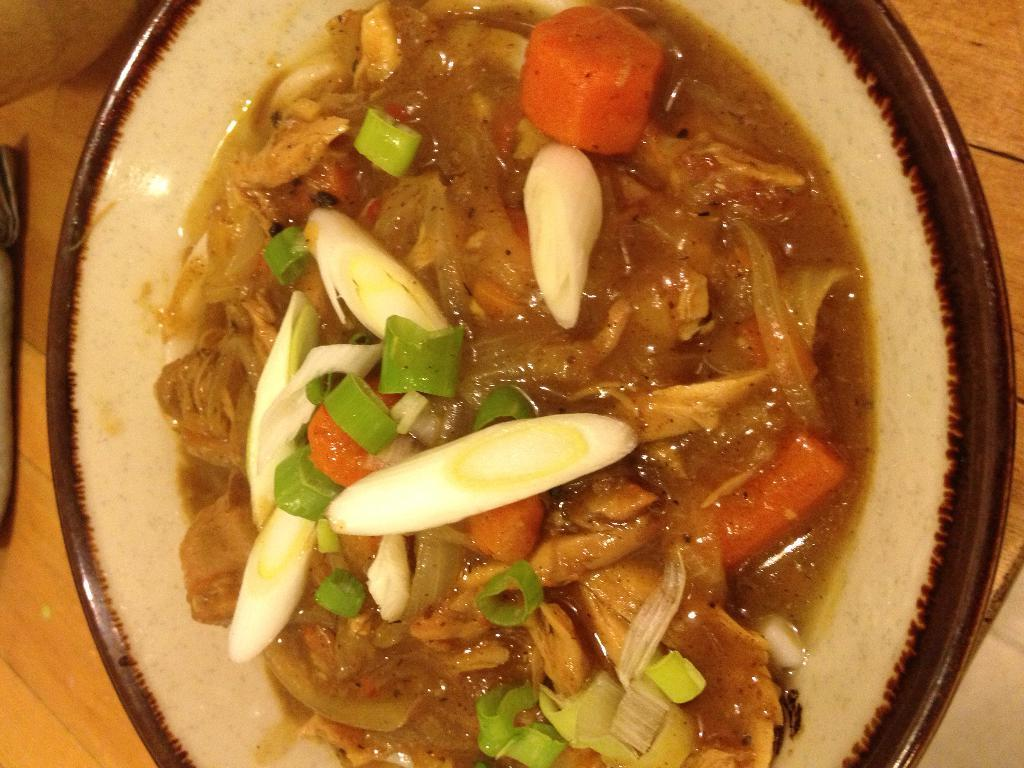What is on the plate that is visible in the image? There is a plate containing food in the image. Where is the plate placed in the image? The plate is placed on a wooden table. What is the color of the object on the table? There is an object in black color on the table. What type of harmony is being played by the band in the image? There is no band present in the image, so it is not possible to determine what type of harmony might be played. 